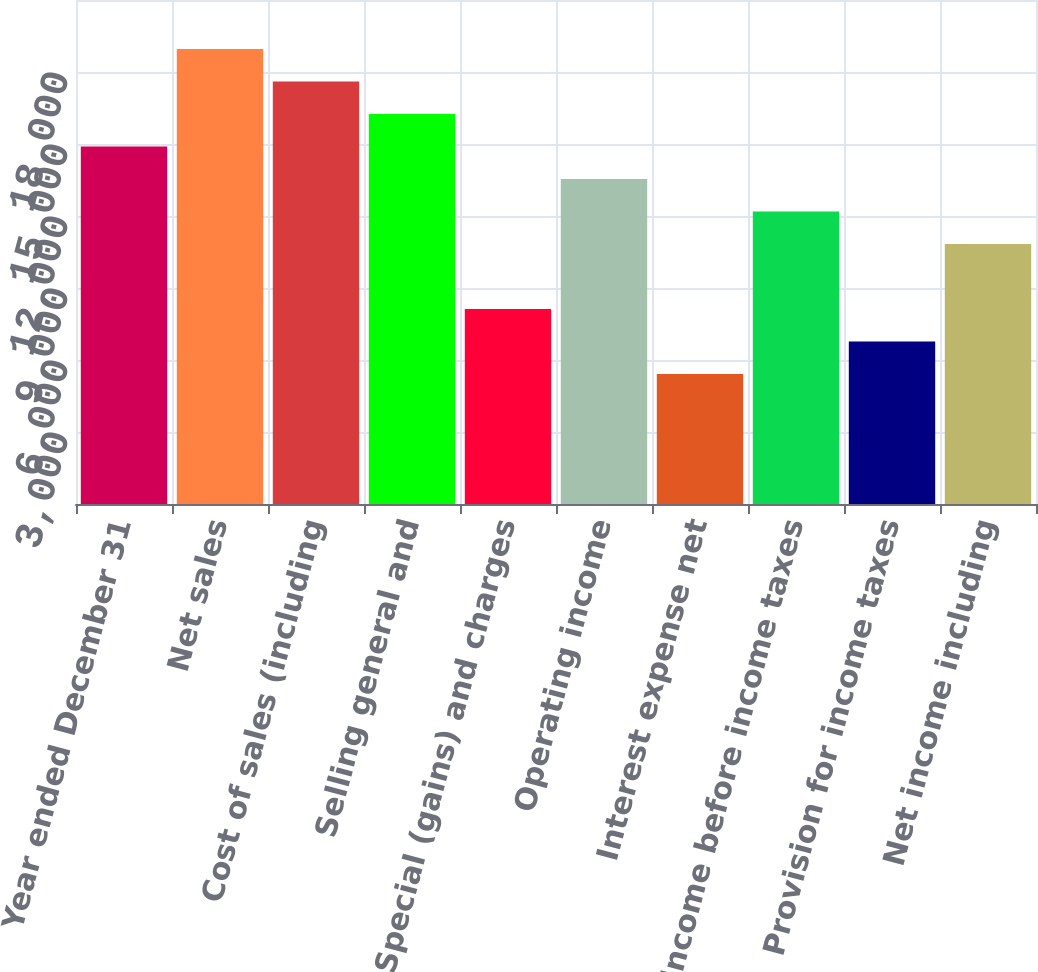Convert chart. <chart><loc_0><loc_0><loc_500><loc_500><bar_chart><fcel>Year ended December 31<fcel>Net sales<fcel>Cost of sales (including<fcel>Selling general and<fcel>Special (gains) and charges<fcel>Operating income<fcel>Interest expense net<fcel>Income before income taxes<fcel>Provision for income taxes<fcel>Net income including<nl><fcel>14899.5<fcel>18962.7<fcel>17608.3<fcel>16253.9<fcel>8127.62<fcel>13545.1<fcel>5418.86<fcel>12190.8<fcel>6773.24<fcel>10836.4<nl></chart> 